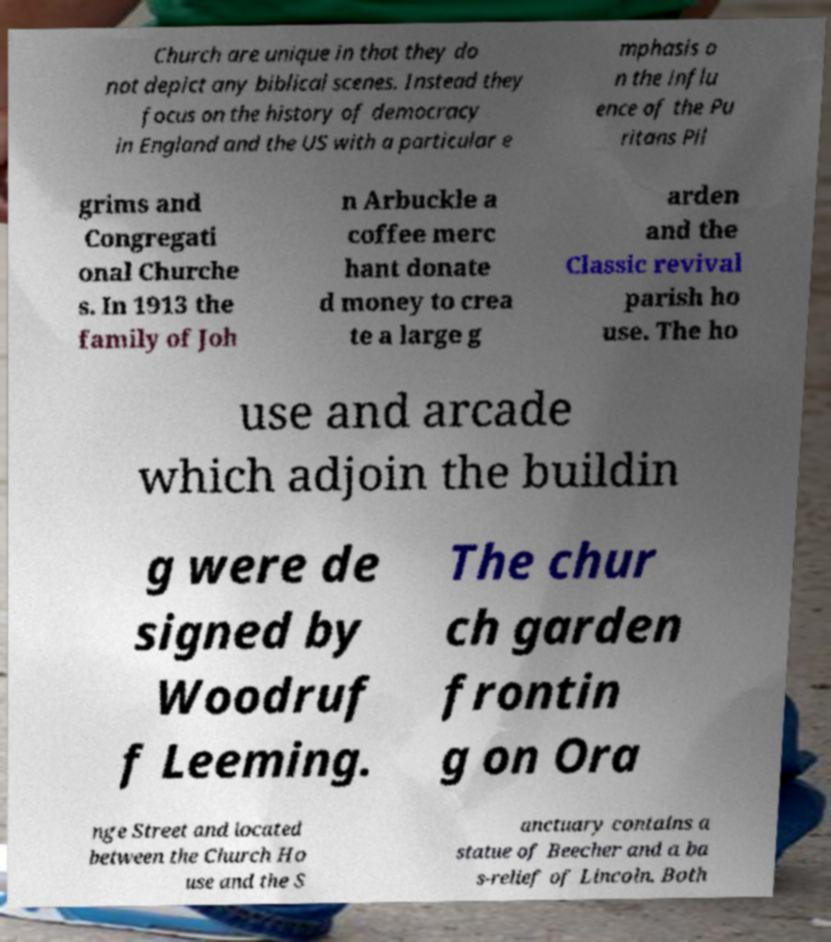Please identify and transcribe the text found in this image. Church are unique in that they do not depict any biblical scenes. Instead they focus on the history of democracy in England and the US with a particular e mphasis o n the influ ence of the Pu ritans Pil grims and Congregati onal Churche s. In 1913 the family of Joh n Arbuckle a coffee merc hant donate d money to crea te a large g arden and the Classic revival parish ho use. The ho use and arcade which adjoin the buildin g were de signed by Woodruf f Leeming. The chur ch garden frontin g on Ora nge Street and located between the Church Ho use and the S anctuary contains a statue of Beecher and a ba s-relief of Lincoln. Both 